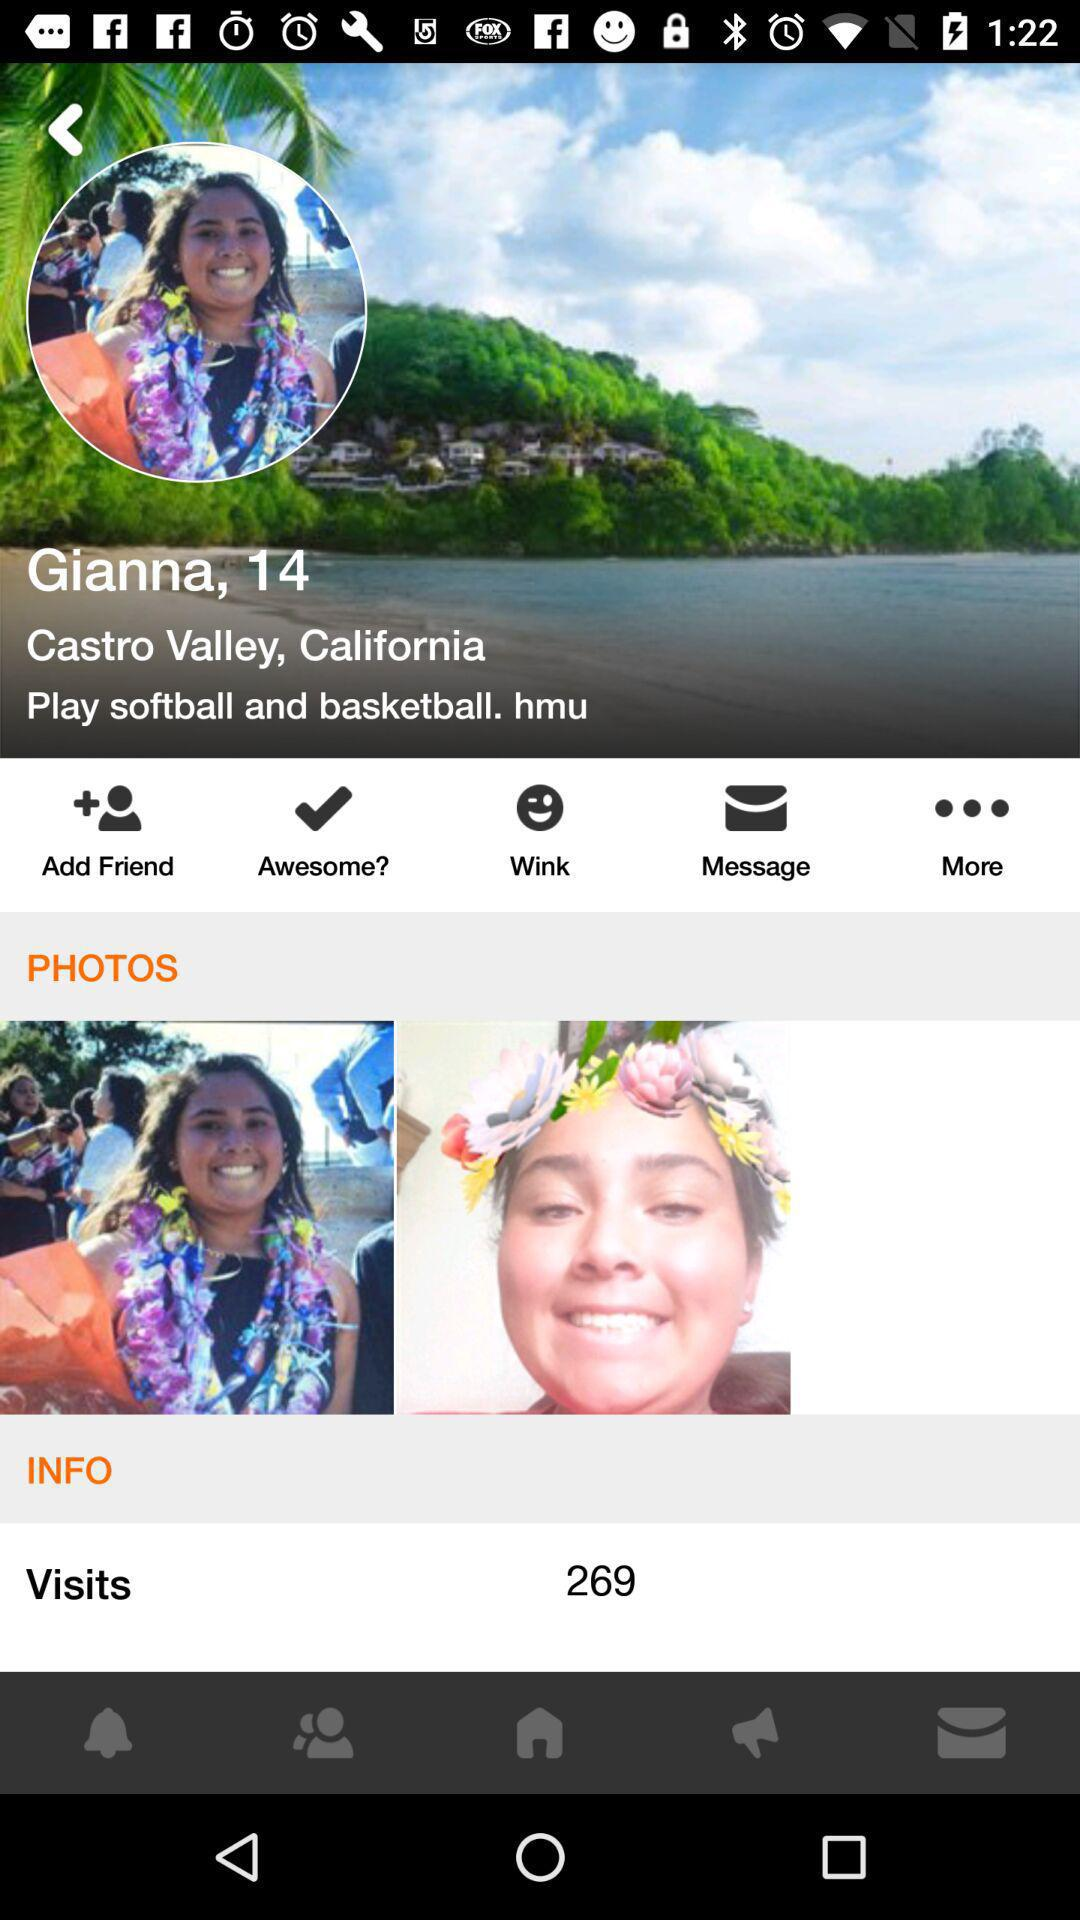How many photos does Gianna have?
Answer the question using a single word or phrase. 2 